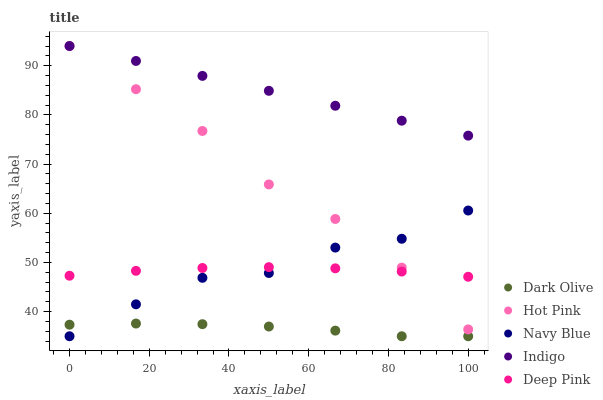Does Dark Olive have the minimum area under the curve?
Answer yes or no. Yes. Does Indigo have the maximum area under the curve?
Answer yes or no. Yes. Does Indigo have the minimum area under the curve?
Answer yes or no. No. Does Dark Olive have the maximum area under the curve?
Answer yes or no. No. Is Indigo the smoothest?
Answer yes or no. Yes. Is Navy Blue the roughest?
Answer yes or no. Yes. Is Dark Olive the smoothest?
Answer yes or no. No. Is Dark Olive the roughest?
Answer yes or no. No. Does Navy Blue have the lowest value?
Answer yes or no. Yes. Does Indigo have the lowest value?
Answer yes or no. No. Does Hot Pink have the highest value?
Answer yes or no. Yes. Does Dark Olive have the highest value?
Answer yes or no. No. Is Dark Olive less than Indigo?
Answer yes or no. Yes. Is Indigo greater than Dark Olive?
Answer yes or no. Yes. Does Navy Blue intersect Hot Pink?
Answer yes or no. Yes. Is Navy Blue less than Hot Pink?
Answer yes or no. No. Is Navy Blue greater than Hot Pink?
Answer yes or no. No. Does Dark Olive intersect Indigo?
Answer yes or no. No. 